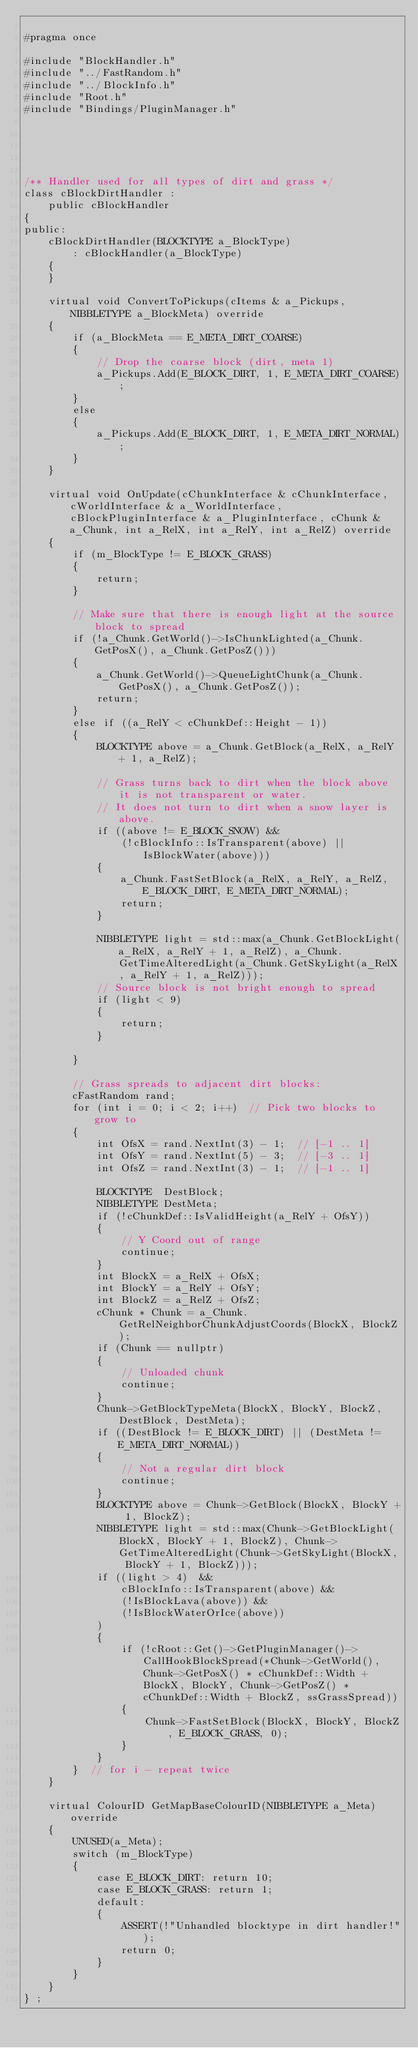Convert code to text. <code><loc_0><loc_0><loc_500><loc_500><_C_>
#pragma once

#include "BlockHandler.h"
#include "../FastRandom.h"
#include "../BlockInfo.h"
#include "Root.h"
#include "Bindings/PluginManager.h"





/** Handler used for all types of dirt and grass */
class cBlockDirtHandler :
	public cBlockHandler
{
public:
	cBlockDirtHandler(BLOCKTYPE a_BlockType)
		: cBlockHandler(a_BlockType)
	{
	}

	virtual void ConvertToPickups(cItems & a_Pickups, NIBBLETYPE a_BlockMeta) override
	{
		if (a_BlockMeta == E_META_DIRT_COARSE)
		{
			// Drop the coarse block (dirt, meta 1)
			a_Pickups.Add(E_BLOCK_DIRT, 1, E_META_DIRT_COARSE);
		}
		else
		{
			a_Pickups.Add(E_BLOCK_DIRT, 1, E_META_DIRT_NORMAL);
		}
	}

	virtual void OnUpdate(cChunkInterface & cChunkInterface, cWorldInterface & a_WorldInterface, cBlockPluginInterface & a_PluginInterface, cChunk & a_Chunk, int a_RelX, int a_RelY, int a_RelZ) override
	{
		if (m_BlockType != E_BLOCK_GRASS)
		{
			return;
		}

		// Make sure that there is enough light at the source block to spread
		if (!a_Chunk.GetWorld()->IsChunkLighted(a_Chunk.GetPosX(), a_Chunk.GetPosZ()))
		{
			a_Chunk.GetWorld()->QueueLightChunk(a_Chunk.GetPosX(), a_Chunk.GetPosZ());
			return;
		}
		else if ((a_RelY < cChunkDef::Height - 1))
		{
			BLOCKTYPE above = a_Chunk.GetBlock(a_RelX, a_RelY + 1, a_RelZ);

			// Grass turns back to dirt when the block above it is not transparent or water.
			// It does not turn to dirt when a snow layer is above.
			if ((above != E_BLOCK_SNOW) &&
				(!cBlockInfo::IsTransparent(above) || IsBlockWater(above)))
			{
				a_Chunk.FastSetBlock(a_RelX, a_RelY, a_RelZ, E_BLOCK_DIRT, E_META_DIRT_NORMAL);
				return;
			}

			NIBBLETYPE light = std::max(a_Chunk.GetBlockLight(a_RelX, a_RelY + 1, a_RelZ), a_Chunk.GetTimeAlteredLight(a_Chunk.GetSkyLight(a_RelX, a_RelY + 1, a_RelZ)));
			// Source block is not bright enough to spread
			if (light < 9)
			{
				return;
			}

		}

		// Grass spreads to adjacent dirt blocks:
		cFastRandom rand;
		for (int i = 0; i < 2; i++)  // Pick two blocks to grow to
		{
			int OfsX = rand.NextInt(3) - 1;  // [-1 .. 1]
			int OfsY = rand.NextInt(5) - 3;  // [-3 .. 1]
			int OfsZ = rand.NextInt(3) - 1;  // [-1 .. 1]

			BLOCKTYPE  DestBlock;
			NIBBLETYPE DestMeta;
			if (!cChunkDef::IsValidHeight(a_RelY + OfsY))
			{
				// Y Coord out of range
				continue;
			}
			int BlockX = a_RelX + OfsX;
			int BlockY = a_RelY + OfsY;
			int BlockZ = a_RelZ + OfsZ;
			cChunk * Chunk = a_Chunk.GetRelNeighborChunkAdjustCoords(BlockX, BlockZ);
			if (Chunk == nullptr)
			{
				// Unloaded chunk
				continue;
			}
			Chunk->GetBlockTypeMeta(BlockX, BlockY, BlockZ, DestBlock, DestMeta);
			if ((DestBlock != E_BLOCK_DIRT) || (DestMeta != E_META_DIRT_NORMAL))
			{
				// Not a regular dirt block
				continue;
			}
			BLOCKTYPE above = Chunk->GetBlock(BlockX, BlockY + 1, BlockZ);
			NIBBLETYPE light = std::max(Chunk->GetBlockLight(BlockX, BlockY + 1, BlockZ), Chunk->GetTimeAlteredLight(Chunk->GetSkyLight(BlockX, BlockY + 1, BlockZ)));
			if ((light > 4)  &&
				cBlockInfo::IsTransparent(above) &&
				(!IsBlockLava(above)) &&
				(!IsBlockWaterOrIce(above))
			)
			{
				if (!cRoot::Get()->GetPluginManager()->CallHookBlockSpread(*Chunk->GetWorld(), Chunk->GetPosX() * cChunkDef::Width + BlockX, BlockY, Chunk->GetPosZ() * cChunkDef::Width + BlockZ, ssGrassSpread))
				{
					Chunk->FastSetBlock(BlockX, BlockY, BlockZ, E_BLOCK_GRASS, 0);
				}
			}
		}  // for i - repeat twice
	}

	virtual ColourID GetMapBaseColourID(NIBBLETYPE a_Meta) override
	{
		UNUSED(a_Meta);
		switch (m_BlockType)
		{
			case E_BLOCK_DIRT: return 10;
			case E_BLOCK_GRASS: return 1;
			default:
			{
				ASSERT(!"Unhandled blocktype in dirt handler!");
				return 0;
			}
		}
	}
} ;




</code> 